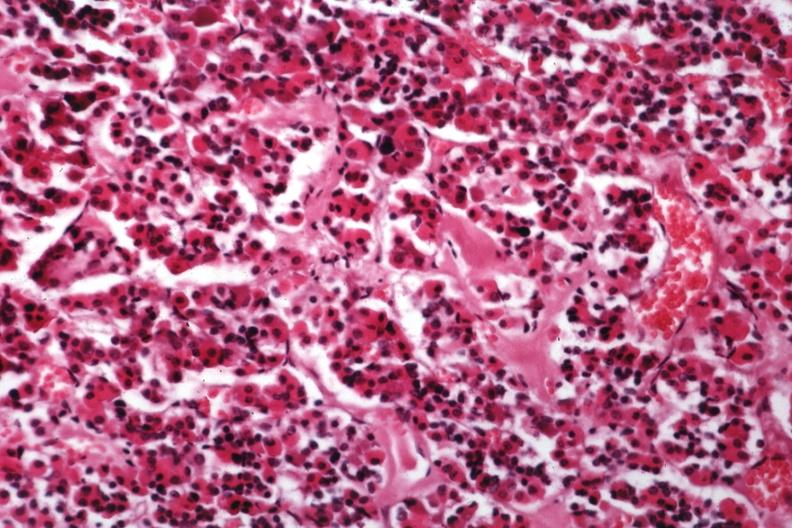what is present?
Answer the question using a single word or phrase. Endocrine 